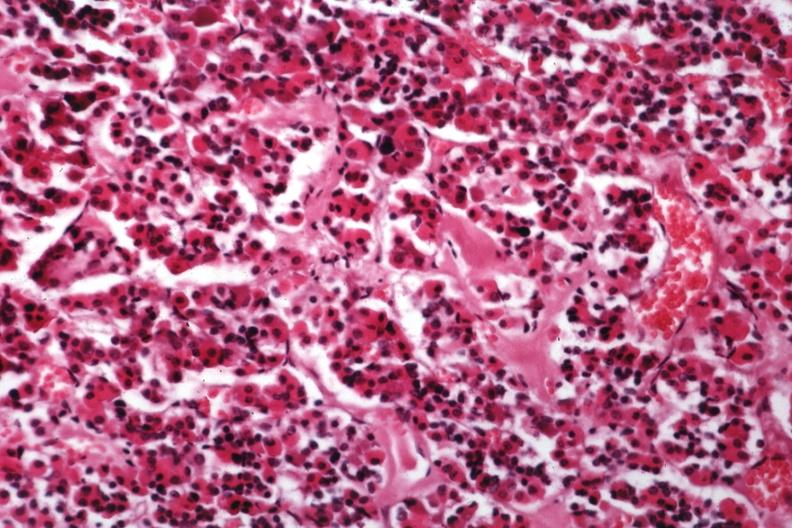what is present?
Answer the question using a single word or phrase. Endocrine 